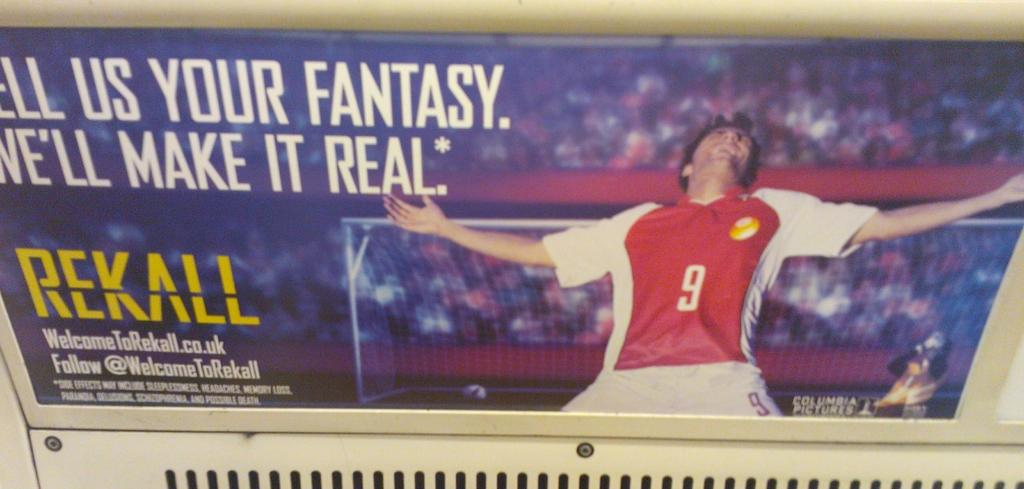Provide a one-sentence caption for the provided image. A soccer advertisement with a player wearing the number 9 jersey celebrating a goal. 